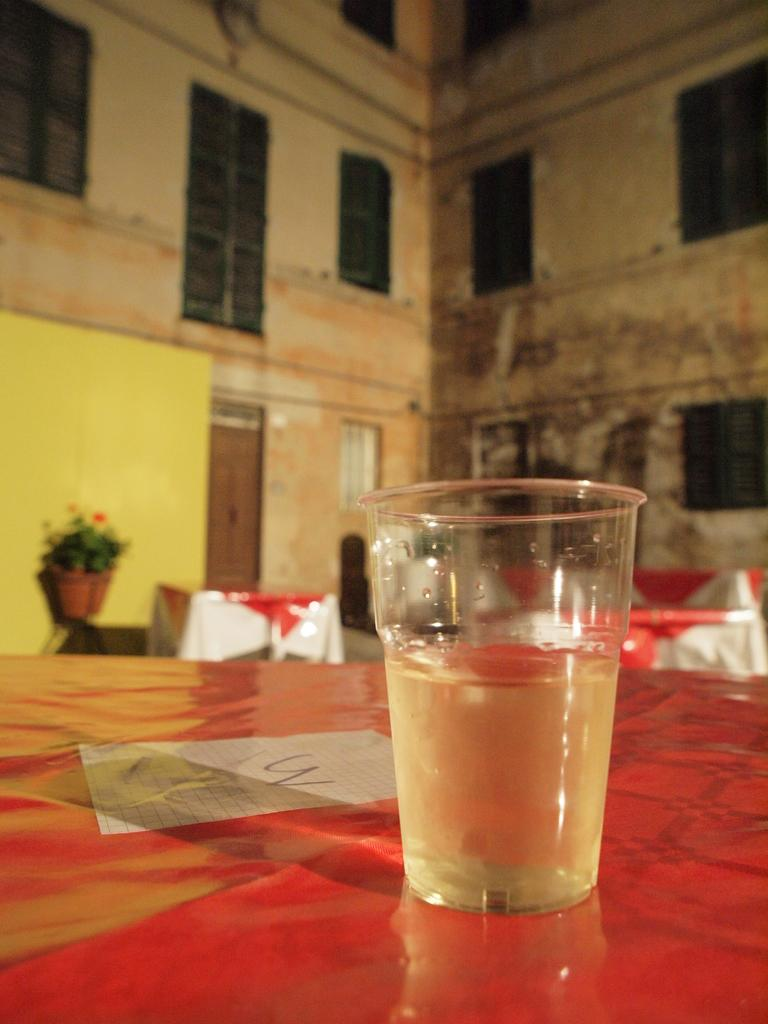What is in the image that can hold liquid? There is a water glass in the image. What is on the surface in the image? There is a paper on the surface in the image. What type of structure is visible in the image? There is a building with windows and doors in the image. What is located in front of the building in the image? There are tables and flower pots in front of the building in the image. How many fangs can be seen on the plantation in the image? There is no plantation or fangs present in the image. What type of dogs are sitting near the flower pots in the image? There are no dogs present in the image. 